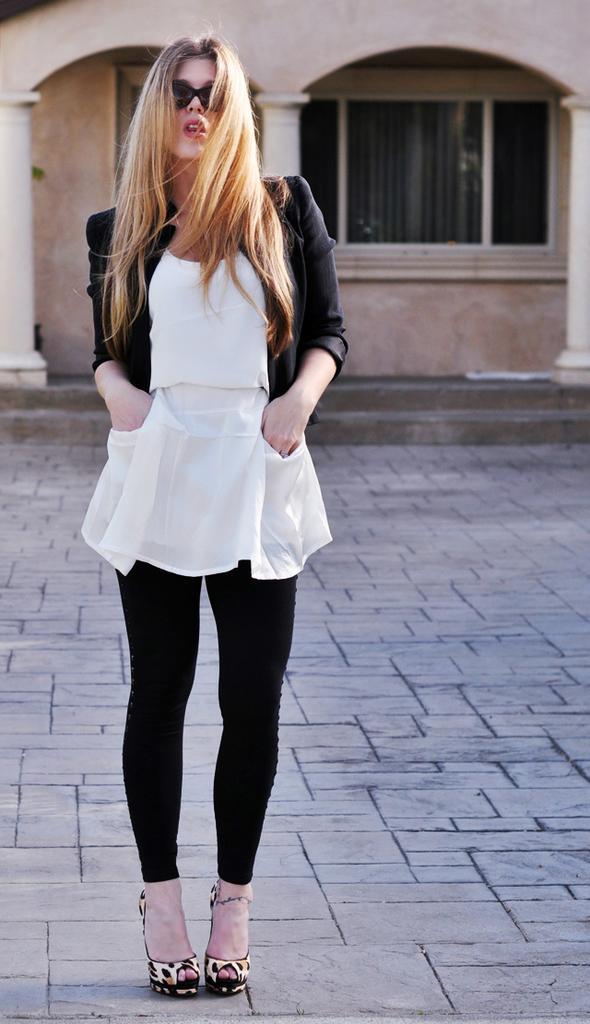Describe this image in one or two sentences. In this image we can see a woman standing on the floor. In the background there are windows and walls. 